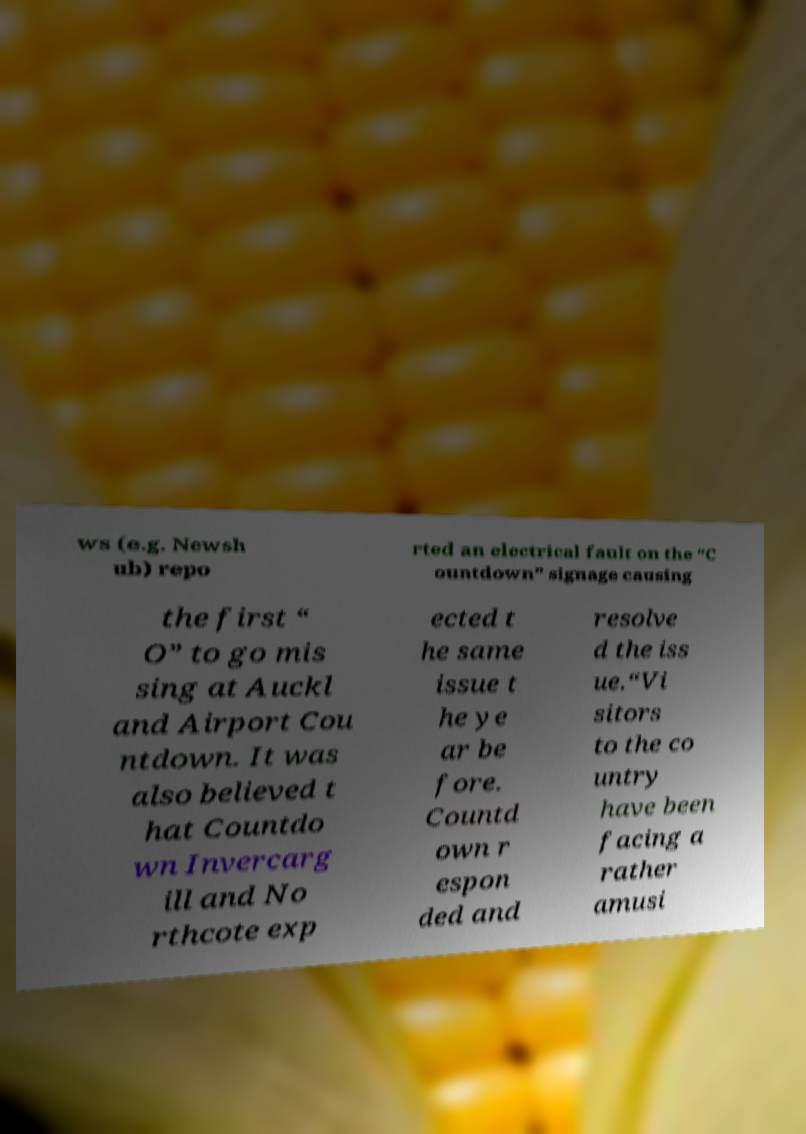There's text embedded in this image that I need extracted. Can you transcribe it verbatim? ws (e.g. Newsh ub) repo rted an electrical fault on the “C ountdown” signage causing the first “ O” to go mis sing at Auckl and Airport Cou ntdown. It was also believed t hat Countdo wn Invercarg ill and No rthcote exp ected t he same issue t he ye ar be fore. Countd own r espon ded and resolve d the iss ue.“Vi sitors to the co untry have been facing a rather amusi 